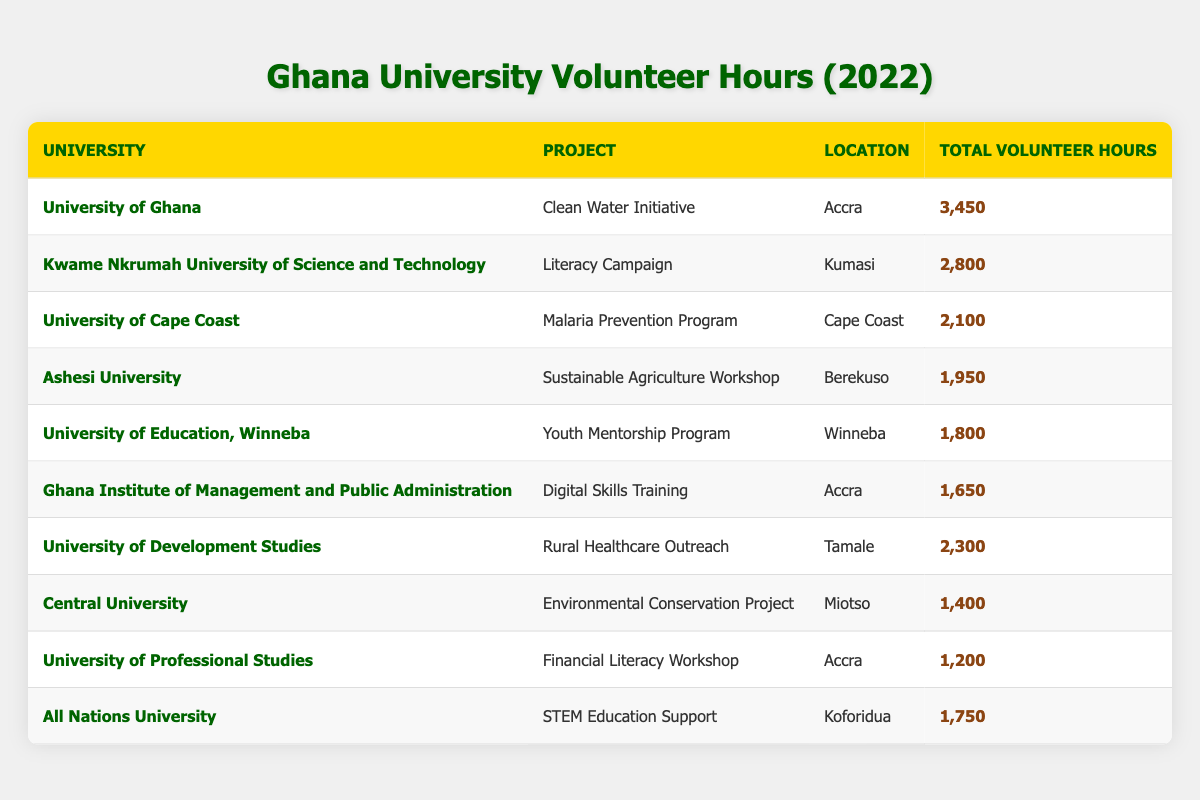What university contributed the most volunteer hours? By looking at the 'Total Volunteer Hours' column, we can identify that the University of Ghana has the highest figure at 3,450 volunteer hours.
Answer: University of Ghana Which university was involved in the "Rural Healthcare Outreach" project? The "Rural Healthcare Outreach" project was undertaken by the University of Development Studies, as noted in the 'Project' column.
Answer: University of Development Studies How many total volunteer hours were contributed by all universities combined in 2022? To find the total volunteer hours, we add up the hours from each university: 3450 + 2800 + 2100 + 1950 + 1800 + 1650 + 2300 + 1400 + 1200 + 1750 = 20,500.
Answer: 20500 Is the total volunteer hours contributed by Kwame Nkrumah University of Science and Technology greater than 2,500? The 'Total Volunteer Hours' for Kwame Nkrumah University of Science and Technology is 2,800, which is indeed greater than 2,500.
Answer: Yes What is the average total volunteer hours contributed by universities in coastal regions like Cape Coast and Accra? First, we identify the relevant universities: University of Ghana (3,450), University of Cape Coast (2,100), and University of Professional Studies (1,200). Now sum these hours: 3450 + 2100 + 1200 = 6,750. There are three observations, so the average is 6,750 / 3 = 2,250.
Answer: 2250 Which project had the least total volunteer hours, and how many hours were contributed? From the 'Total Volunteer Hours' column, we see that the project with the least hours is the Financial Literacy Workshop, which received 1,200 hours.
Answer: Financial Literacy Workshop, 1200 Did any project in Accra contribute less than 1,700 volunteer hours? Upon examining the data, we see that both the Financial Literacy Workshop (1,200 hours) and Digital Skills Training (1,650 hours) took place in Accra, contributing less than 1,700 hours.
Answer: Yes What is the difference in total volunteer hours between the project with the highest and the project with the lowest contributions? The project with the highest total volunteer hours is the Clean Water Initiative (3,450 hours), and the project with the lowest is the Financial Literacy Workshop (1,200 hours). The difference is calculated as 3,450 - 1,200 = 2,250 hours.
Answer: 2250 